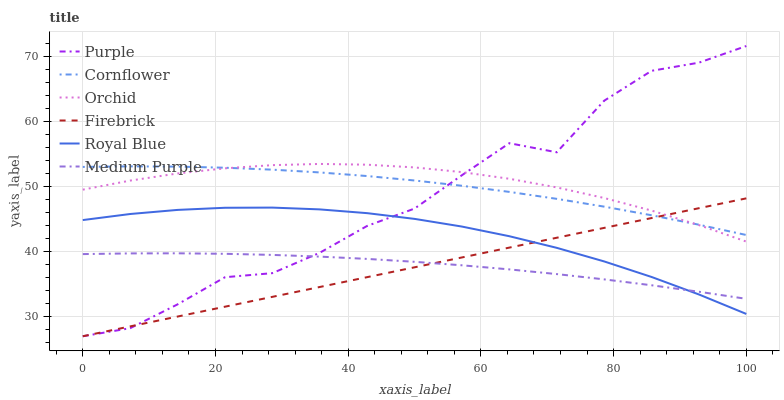Does Firebrick have the minimum area under the curve?
Answer yes or no. Yes. Does Orchid have the maximum area under the curve?
Answer yes or no. Yes. Does Purple have the minimum area under the curve?
Answer yes or no. No. Does Purple have the maximum area under the curve?
Answer yes or no. No. Is Firebrick the smoothest?
Answer yes or no. Yes. Is Purple the roughest?
Answer yes or no. Yes. Is Purple the smoothest?
Answer yes or no. No. Is Firebrick the roughest?
Answer yes or no. No. Does Purple have the lowest value?
Answer yes or no. Yes. Does Medium Purple have the lowest value?
Answer yes or no. No. Does Purple have the highest value?
Answer yes or no. Yes. Does Firebrick have the highest value?
Answer yes or no. No. Is Medium Purple less than Orchid?
Answer yes or no. Yes. Is Cornflower greater than Medium Purple?
Answer yes or no. Yes. Does Medium Purple intersect Royal Blue?
Answer yes or no. Yes. Is Medium Purple less than Royal Blue?
Answer yes or no. No. Is Medium Purple greater than Royal Blue?
Answer yes or no. No. Does Medium Purple intersect Orchid?
Answer yes or no. No. 